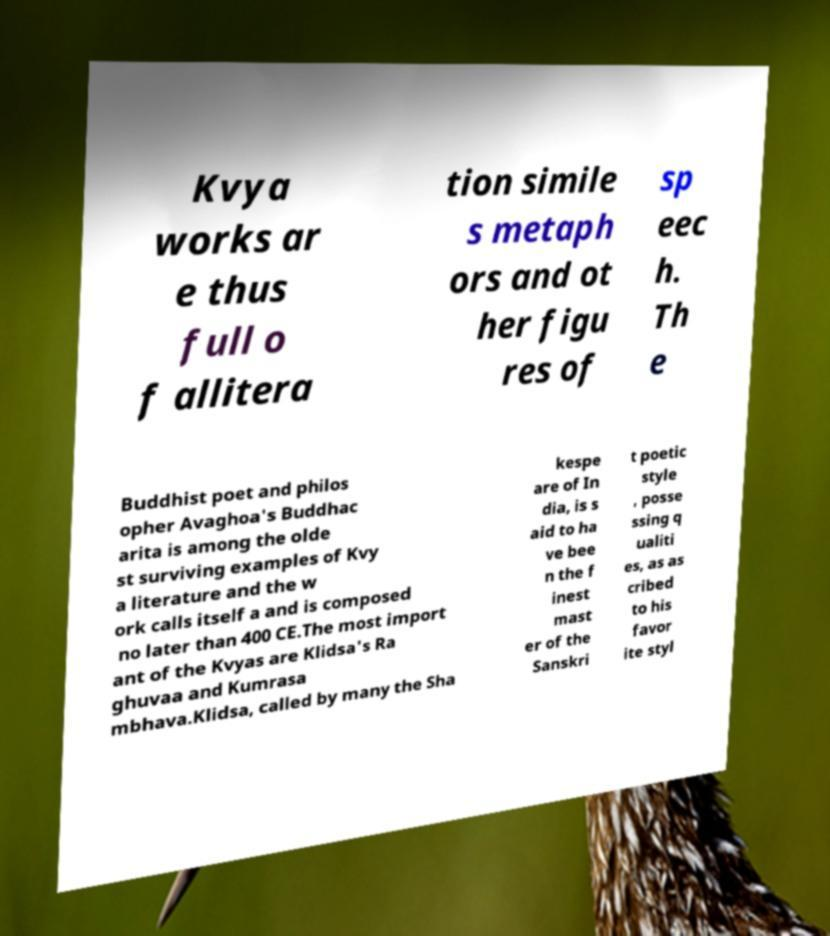Please read and relay the text visible in this image. What does it say? Kvya works ar e thus full o f allitera tion simile s metaph ors and ot her figu res of sp eec h. Th e Buddhist poet and philos opher Avaghoa's Buddhac arita is among the olde st surviving examples of Kvy a literature and the w ork calls itself a and is composed no later than 400 CE.The most import ant of the Kvyas are Klidsa's Ra ghuvaa and Kumrasa mbhava.Klidsa, called by many the Sha kespe are of In dia, is s aid to ha ve bee n the f inest mast er of the Sanskri t poetic style , posse ssing q ualiti es, as as cribed to his favor ite styl 